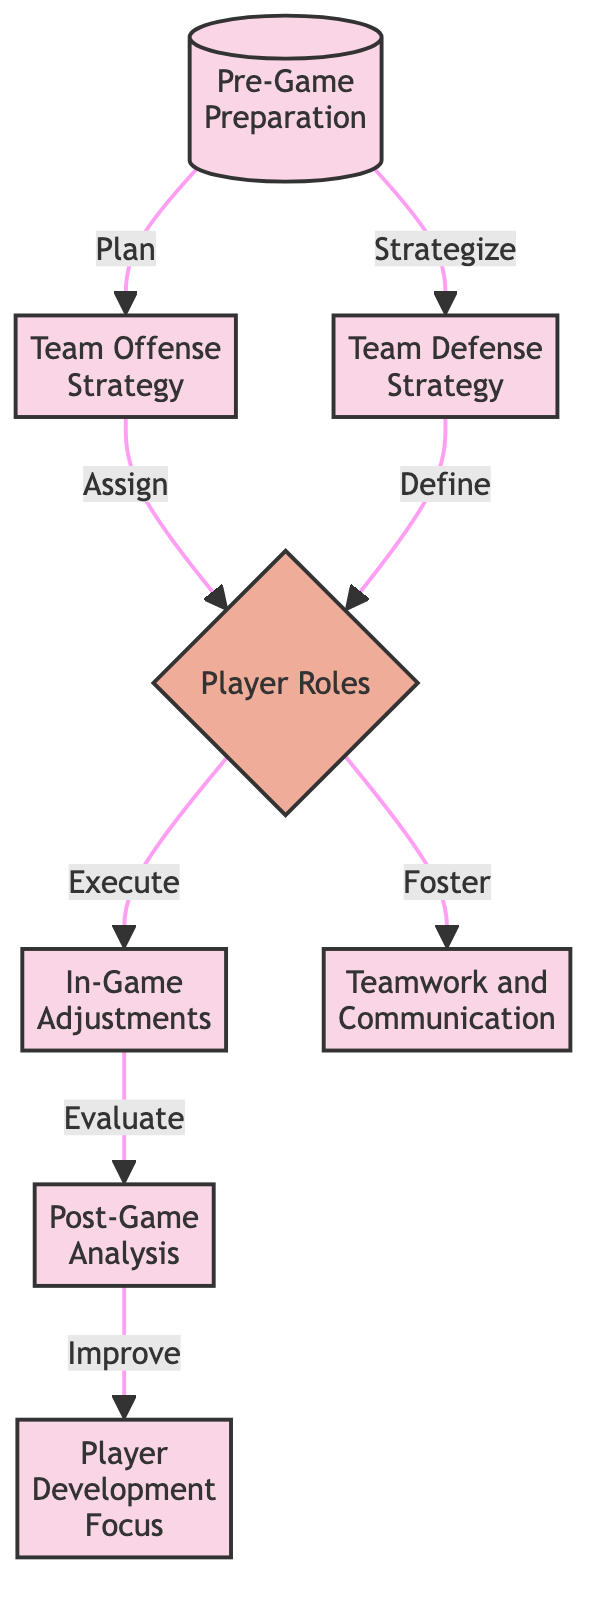What is the first step in the basketball game strategy? The flow chart starts with "Pre-Game Preparation," which is the first process step in the diagram.
Answer: Pre-Game Preparation How many total process nodes are in the diagram? By counting the nodes, there are six process nodes: Pre-Game Preparation, Team Offense Strategy, Team Defense Strategy, In-Game Adjustments, Post-Game Analysis, and Player Development Focus.
Answer: Six Which process node directly follows "Team Offense Strategy"? The arrow from "Team Offense Strategy" points to "Player Roles," indicating that it is the next step directly after Team Offense Strategy.
Answer: Player Roles What action leads to "In-Game Adjustments"? The diagram shows that the action "Execute" from the decision "Player Roles" leads directly to the process "In-Game Adjustments."
Answer: Execute What is the last step in the strategy overview? The last node connected in the flow chart is "Player Development Focus," which follows "Post-Game Analysis."
Answer: Player Development Focus Which two process nodes are connected by the decision node "Player Roles"? "Team Offense Strategy" and "Team Defense Strategy" both connect to "Player Roles," indicating that they both lead to this decision.
Answer: Team Offense Strategy and Team Defense Strategy How does the diagram show communication is emphasized in the strategy? The diagram indicates that "Player Roles" connects to "Teamwork and Communication," suggesting that fostering teamwork is integral to defining player roles.
Answer: Foster What is the main relationship represented between "In-Game Adjustments" and "Post-Game Analysis"? The diagram shows that after "In-Game Adjustments," the next step in the process flow is "Post-Game Analysis," indicating a sequential relationship where evaluation follows adjustments.
Answer: Evaluation 